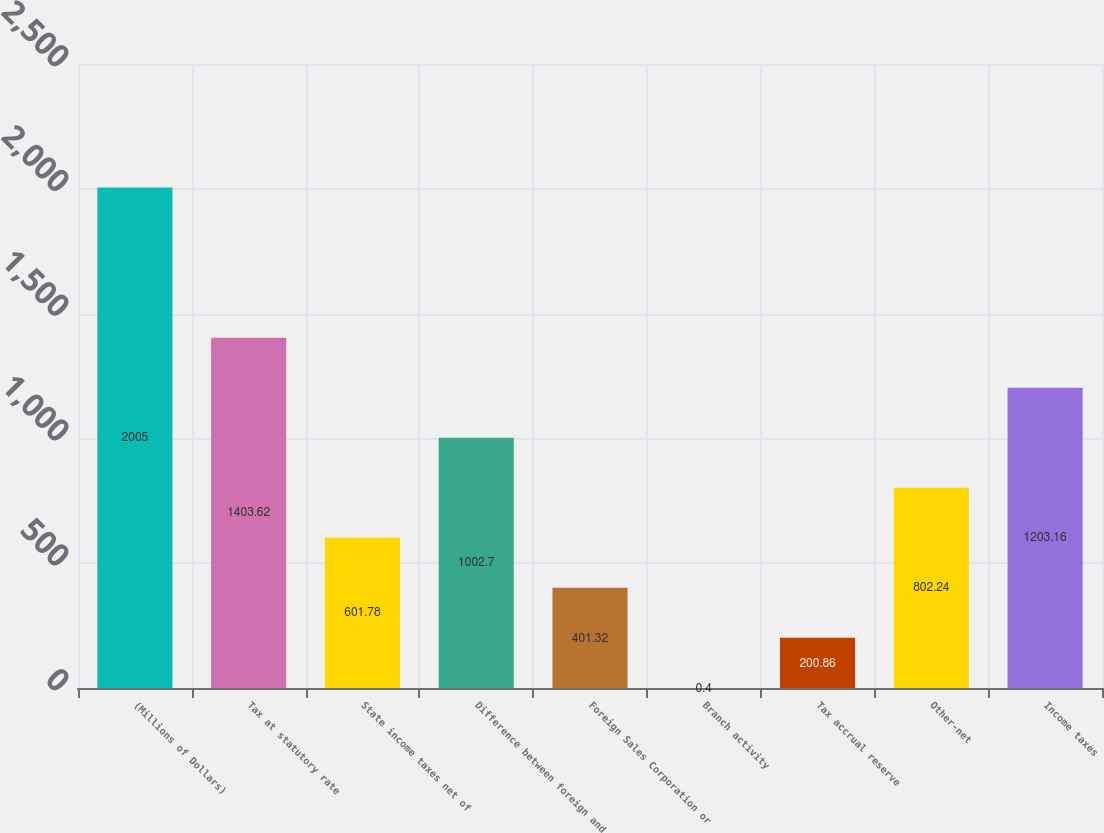Convert chart to OTSL. <chart><loc_0><loc_0><loc_500><loc_500><bar_chart><fcel>(Millions of Dollars)<fcel>Tax at statutory rate<fcel>State income taxes net of<fcel>Difference between foreign and<fcel>Foreign Sales Corporation or<fcel>Branch activity<fcel>Tax accrual reserve<fcel>Other-net<fcel>Income taxes<nl><fcel>2005<fcel>1403.62<fcel>601.78<fcel>1002.7<fcel>401.32<fcel>0.4<fcel>200.86<fcel>802.24<fcel>1203.16<nl></chart> 